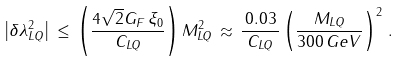<formula> <loc_0><loc_0><loc_500><loc_500>\left | \delta \lambda ^ { 2 } _ { L Q } \right | \, \leq \, \left ( \frac { 4 \sqrt { 2 } G _ { F } \, \xi _ { 0 } } { C _ { L Q } } \right ) M ^ { 2 } _ { L Q } \, \approx \, \frac { \, 0 . 0 3 \, } { C _ { L Q } } \left ( \frac { M _ { L Q } } { 3 0 0 \, G e V } \right ) ^ { 2 } \, .</formula> 